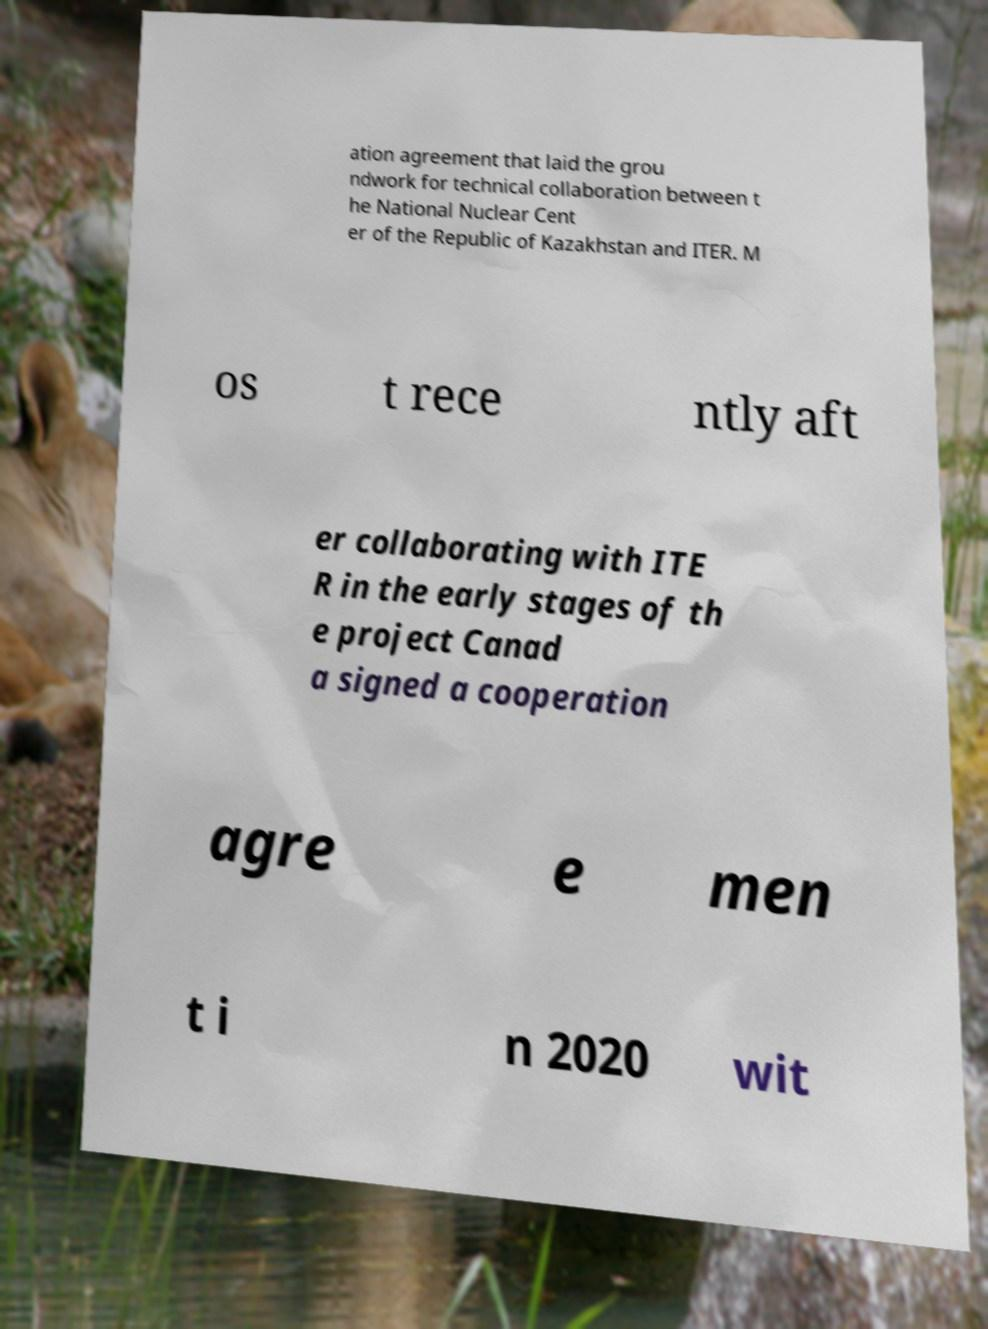Could you extract and type out the text from this image? ation agreement that laid the grou ndwork for technical collaboration between t he National Nuclear Cent er of the Republic of Kazakhstan and ITER. M os t rece ntly aft er collaborating with ITE R in the early stages of th e project Canad a signed a cooperation agre e men t i n 2020 wit 